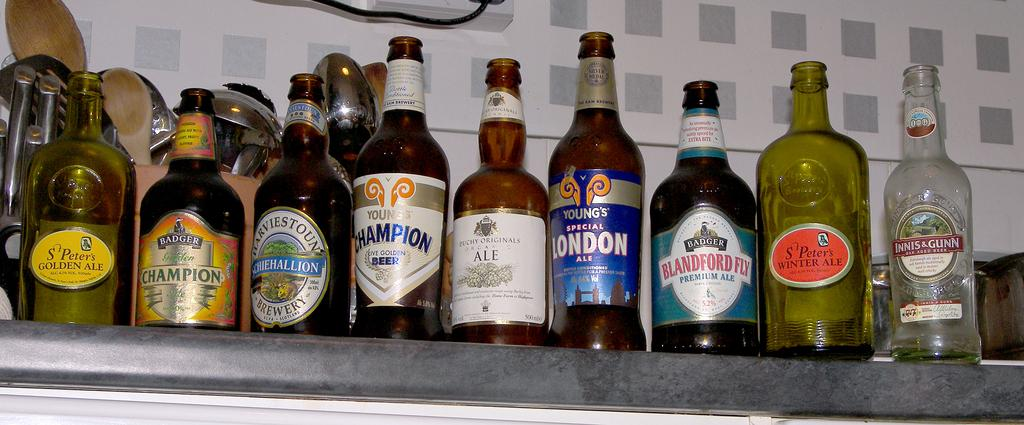<image>
Share a concise interpretation of the image provided. Several bottles of beer, one of which is labelled London. 